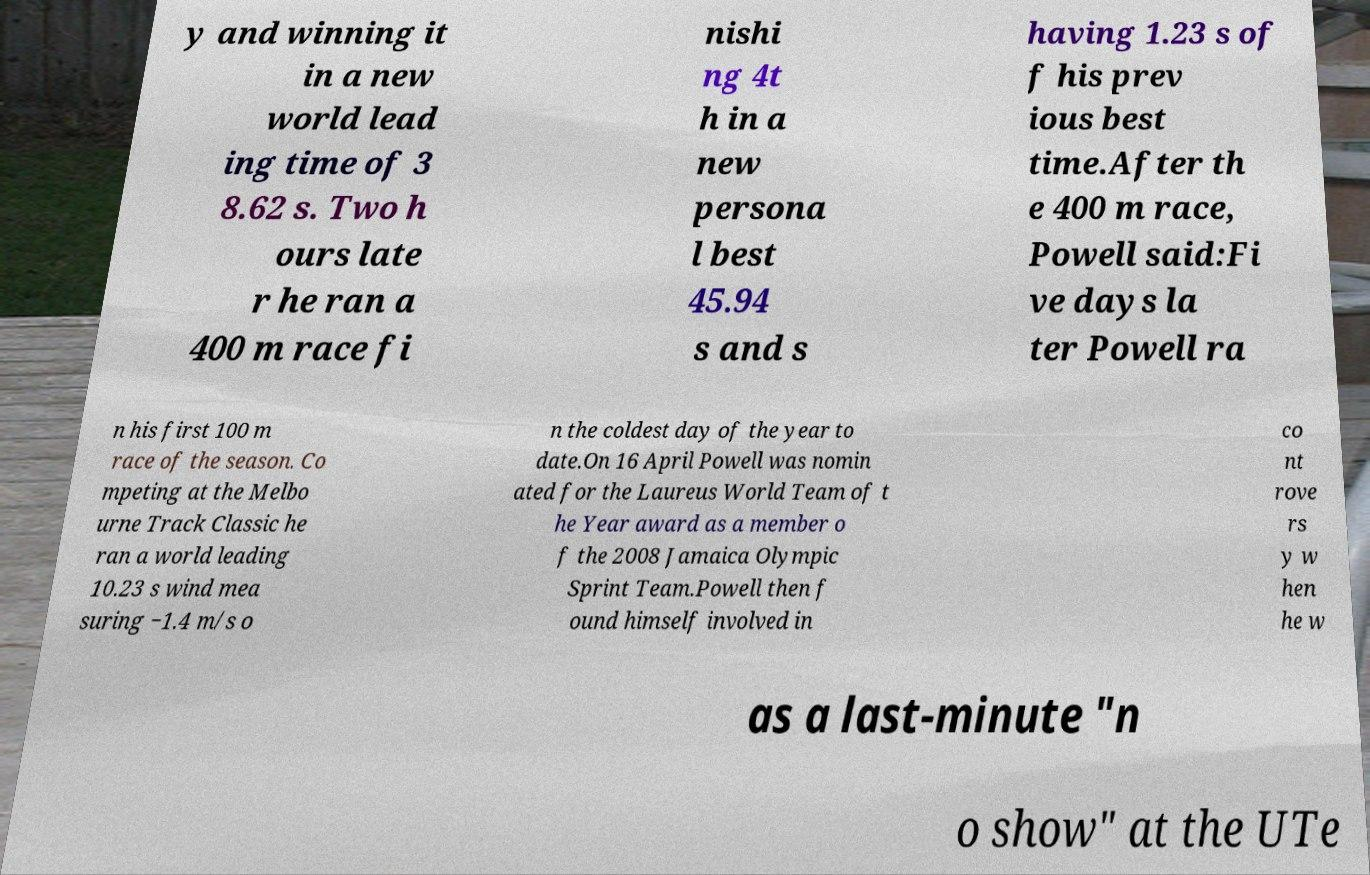Could you assist in decoding the text presented in this image and type it out clearly? y and winning it in a new world lead ing time of 3 8.62 s. Two h ours late r he ran a 400 m race fi nishi ng 4t h in a new persona l best 45.94 s and s having 1.23 s of f his prev ious best time.After th e 400 m race, Powell said:Fi ve days la ter Powell ra n his first 100 m race of the season. Co mpeting at the Melbo urne Track Classic he ran a world leading 10.23 s wind mea suring −1.4 m/s o n the coldest day of the year to date.On 16 April Powell was nomin ated for the Laureus World Team of t he Year award as a member o f the 2008 Jamaica Olympic Sprint Team.Powell then f ound himself involved in co nt rove rs y w hen he w as a last-minute "n o show" at the UTe 